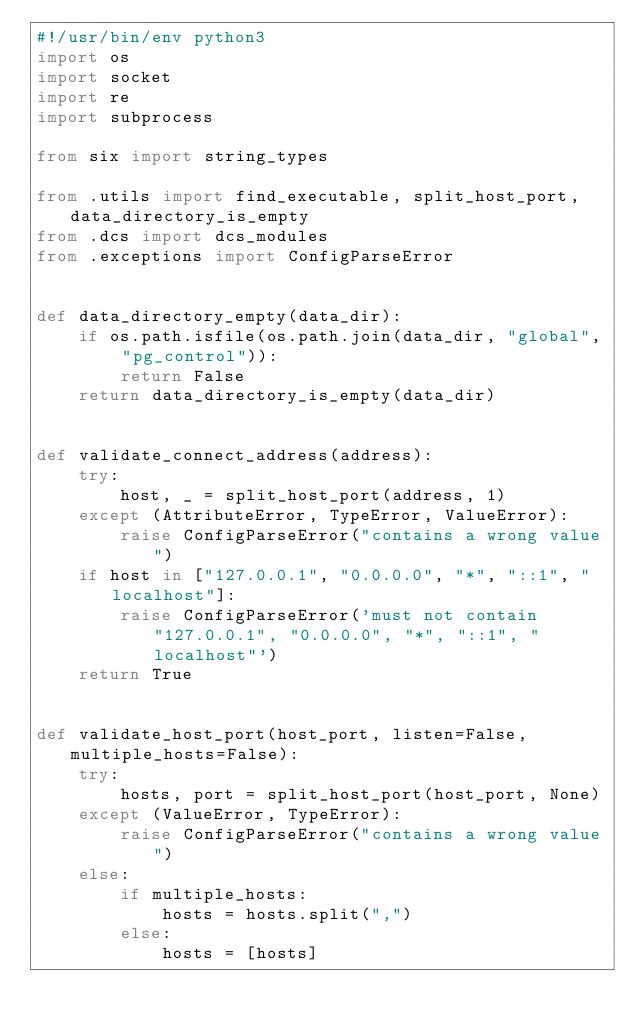Convert code to text. <code><loc_0><loc_0><loc_500><loc_500><_Python_>#!/usr/bin/env python3
import os
import socket
import re
import subprocess

from six import string_types

from .utils import find_executable, split_host_port, data_directory_is_empty
from .dcs import dcs_modules
from .exceptions import ConfigParseError


def data_directory_empty(data_dir):
    if os.path.isfile(os.path.join(data_dir, "global", "pg_control")):
        return False
    return data_directory_is_empty(data_dir)


def validate_connect_address(address):
    try:
        host, _ = split_host_port(address, 1)
    except (AttributeError, TypeError, ValueError):
        raise ConfigParseError("contains a wrong value")
    if host in ["127.0.0.1", "0.0.0.0", "*", "::1", "localhost"]:
        raise ConfigParseError('must not contain "127.0.0.1", "0.0.0.0", "*", "::1", "localhost"')
    return True


def validate_host_port(host_port, listen=False, multiple_hosts=False):
    try:
        hosts, port = split_host_port(host_port, None)
    except (ValueError, TypeError):
        raise ConfigParseError("contains a wrong value")
    else:
        if multiple_hosts:
            hosts = hosts.split(",")
        else:
            hosts = [hosts]</code> 